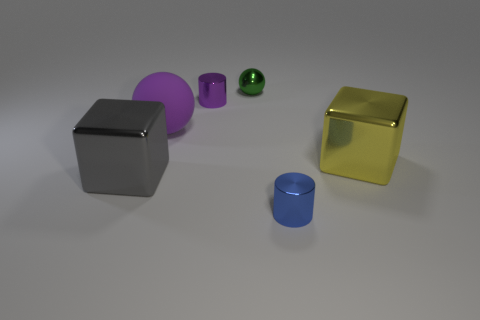Are there any other things that have the same material as the purple sphere?
Offer a terse response. No. How many tiny cylinders are right of the purple cylinder?
Give a very brief answer. 1. What number of green things are there?
Offer a terse response. 1. Is the gray thing the same size as the blue cylinder?
Your response must be concise. No. Is there a tiny shiny sphere behind the block that is on the left side of the sphere that is to the left of the small green shiny object?
Give a very brief answer. Yes. There is another small object that is the same shape as the small blue object; what is its material?
Your answer should be very brief. Metal. There is a big cube on the right side of the tiny purple metallic thing; what is its color?
Provide a succinct answer. Yellow. The green thing is what size?
Your response must be concise. Small. There is a rubber thing; is its size the same as the sphere behind the large purple sphere?
Offer a very short reply. No. The big metal object that is in front of the metal block on the right side of the metallic cylinder in front of the gray metal thing is what color?
Ensure brevity in your answer.  Gray. 